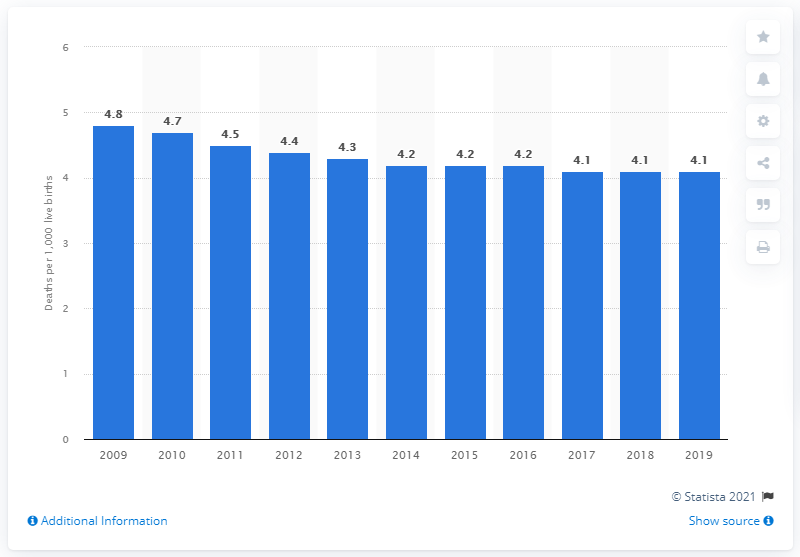Mention a couple of crucial points in this snapshot. In 2019, the infant mortality rate in Croatia was 4.1 deaths per 1,000 live births. 